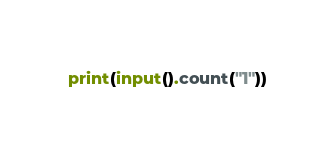Convert code to text. <code><loc_0><loc_0><loc_500><loc_500><_Python_>print(input().count("1"))</code> 